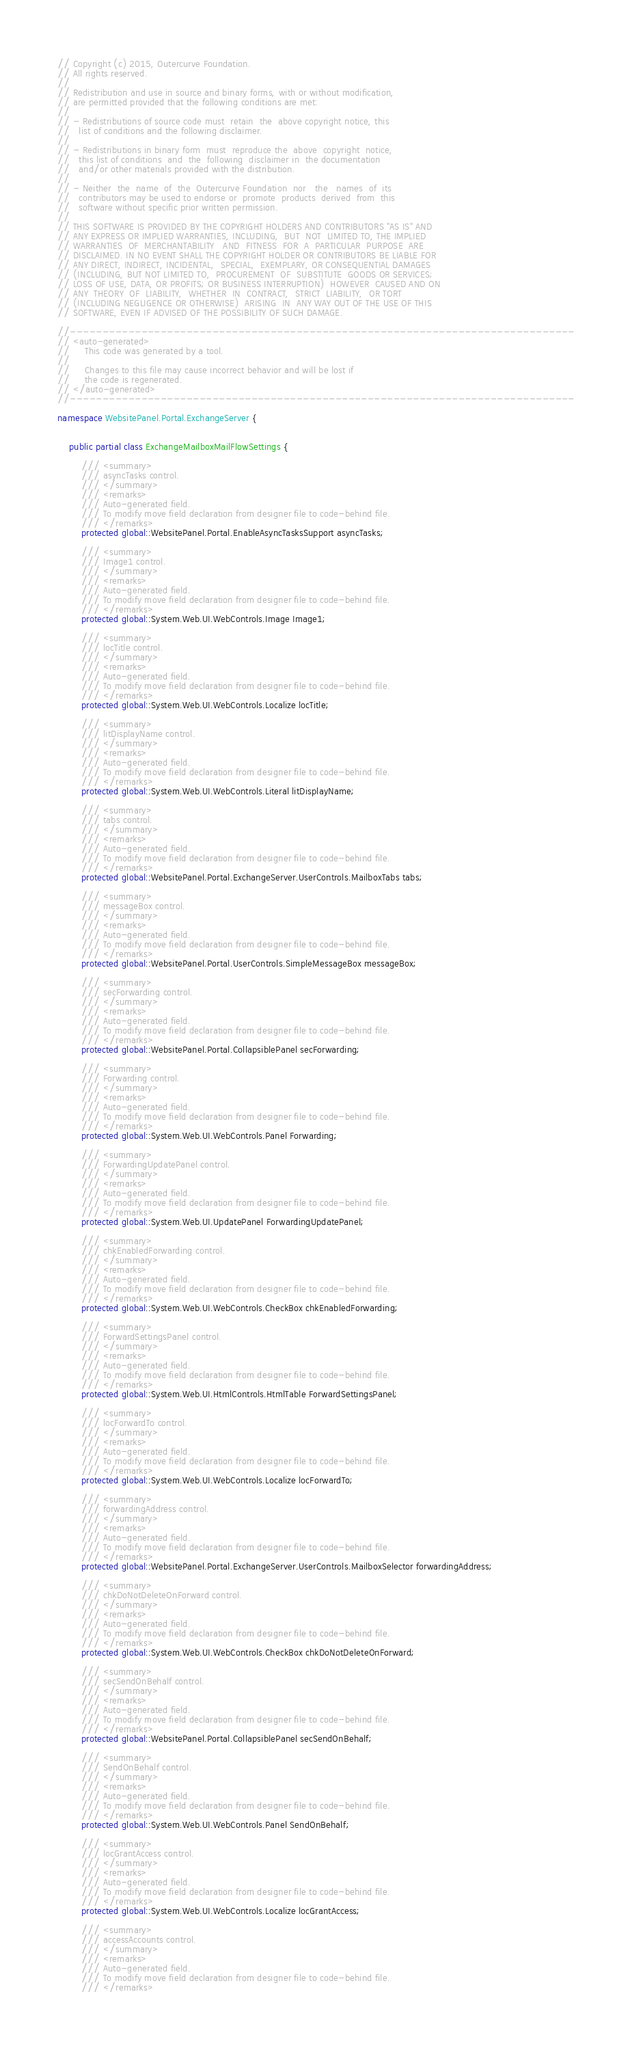<code> <loc_0><loc_0><loc_500><loc_500><_C#_>// Copyright (c) 2015, Outercurve Foundation.
// All rights reserved.
//
// Redistribution and use in source and binary forms, with or without modification,
// are permitted provided that the following conditions are met:
//
// - Redistributions of source code must  retain  the  above copyright notice, this
//   list of conditions and the following disclaimer.
//
// - Redistributions in binary form  must  reproduce the  above  copyright  notice,
//   this list of conditions  and  the  following  disclaimer in  the documentation
//   and/or other materials provided with the distribution.
//
// - Neither  the  name  of  the  Outercurve Foundation  nor   the   names  of  its
//   contributors may be used to endorse or  promote  products  derived  from  this
//   software without specific prior written permission.
//
// THIS SOFTWARE IS PROVIDED BY THE COPYRIGHT HOLDERS AND CONTRIBUTORS "AS IS" AND
// ANY EXPRESS OR IMPLIED WARRANTIES, INCLUDING,  BUT  NOT  LIMITED TO, THE IMPLIED
// WARRANTIES  OF  MERCHANTABILITY   AND  FITNESS  FOR  A  PARTICULAR  PURPOSE  ARE
// DISCLAIMED. IN NO EVENT SHALL THE COPYRIGHT HOLDER OR CONTRIBUTORS BE LIABLE FOR
// ANY DIRECT, INDIRECT, INCIDENTAL,  SPECIAL,  EXEMPLARY, OR CONSEQUENTIAL DAMAGES
// (INCLUDING, BUT NOT LIMITED TO,  PROCUREMENT  OF  SUBSTITUTE  GOODS OR SERVICES;
// LOSS OF USE, DATA, OR PROFITS; OR BUSINESS INTERRUPTION)  HOWEVER  CAUSED AND ON
// ANY  THEORY  OF  LIABILITY,  WHETHER  IN  CONTRACT,  STRICT  LIABILITY,  OR TORT
// (INCLUDING NEGLIGENCE OR OTHERWISE)  ARISING  IN  ANY WAY OUT OF THE USE OF THIS
// SOFTWARE, EVEN IF ADVISED OF THE POSSIBILITY OF SUCH DAMAGE.

//------------------------------------------------------------------------------
// <auto-generated>
//     This code was generated by a tool.
//
//     Changes to this file may cause incorrect behavior and will be lost if
//     the code is regenerated. 
// </auto-generated>
//------------------------------------------------------------------------------

namespace WebsitePanel.Portal.ExchangeServer {
    
    
    public partial class ExchangeMailboxMailFlowSettings {
        
        /// <summary>
        /// asyncTasks control.
        /// </summary>
        /// <remarks>
        /// Auto-generated field.
        /// To modify move field declaration from designer file to code-behind file.
        /// </remarks>
        protected global::WebsitePanel.Portal.EnableAsyncTasksSupport asyncTasks;
        
        /// <summary>
        /// Image1 control.
        /// </summary>
        /// <remarks>
        /// Auto-generated field.
        /// To modify move field declaration from designer file to code-behind file.
        /// </remarks>
        protected global::System.Web.UI.WebControls.Image Image1;
        
        /// <summary>
        /// locTitle control.
        /// </summary>
        /// <remarks>
        /// Auto-generated field.
        /// To modify move field declaration from designer file to code-behind file.
        /// </remarks>
        protected global::System.Web.UI.WebControls.Localize locTitle;
        
        /// <summary>
        /// litDisplayName control.
        /// </summary>
        /// <remarks>
        /// Auto-generated field.
        /// To modify move field declaration from designer file to code-behind file.
        /// </remarks>
        protected global::System.Web.UI.WebControls.Literal litDisplayName;
        
        /// <summary>
        /// tabs control.
        /// </summary>
        /// <remarks>
        /// Auto-generated field.
        /// To modify move field declaration from designer file to code-behind file.
        /// </remarks>
        protected global::WebsitePanel.Portal.ExchangeServer.UserControls.MailboxTabs tabs;
        
        /// <summary>
        /// messageBox control.
        /// </summary>
        /// <remarks>
        /// Auto-generated field.
        /// To modify move field declaration from designer file to code-behind file.
        /// </remarks>
        protected global::WebsitePanel.Portal.UserControls.SimpleMessageBox messageBox;
        
        /// <summary>
        /// secForwarding control.
        /// </summary>
        /// <remarks>
        /// Auto-generated field.
        /// To modify move field declaration from designer file to code-behind file.
        /// </remarks>
        protected global::WebsitePanel.Portal.CollapsiblePanel secForwarding;
        
        /// <summary>
        /// Forwarding control.
        /// </summary>
        /// <remarks>
        /// Auto-generated field.
        /// To modify move field declaration from designer file to code-behind file.
        /// </remarks>
        protected global::System.Web.UI.WebControls.Panel Forwarding;
        
        /// <summary>
        /// ForwardingUpdatePanel control.
        /// </summary>
        /// <remarks>
        /// Auto-generated field.
        /// To modify move field declaration from designer file to code-behind file.
        /// </remarks>
        protected global::System.Web.UI.UpdatePanel ForwardingUpdatePanel;
        
        /// <summary>
        /// chkEnabledForwarding control.
        /// </summary>
        /// <remarks>
        /// Auto-generated field.
        /// To modify move field declaration from designer file to code-behind file.
        /// </remarks>
        protected global::System.Web.UI.WebControls.CheckBox chkEnabledForwarding;
        
        /// <summary>
        /// ForwardSettingsPanel control.
        /// </summary>
        /// <remarks>
        /// Auto-generated field.
        /// To modify move field declaration from designer file to code-behind file.
        /// </remarks>
        protected global::System.Web.UI.HtmlControls.HtmlTable ForwardSettingsPanel;
        
        /// <summary>
        /// locForwardTo control.
        /// </summary>
        /// <remarks>
        /// Auto-generated field.
        /// To modify move field declaration from designer file to code-behind file.
        /// </remarks>
        protected global::System.Web.UI.WebControls.Localize locForwardTo;
        
        /// <summary>
        /// forwardingAddress control.
        /// </summary>
        /// <remarks>
        /// Auto-generated field.
        /// To modify move field declaration from designer file to code-behind file.
        /// </remarks>
        protected global::WebsitePanel.Portal.ExchangeServer.UserControls.MailboxSelector forwardingAddress;
        
        /// <summary>
        /// chkDoNotDeleteOnForward control.
        /// </summary>
        /// <remarks>
        /// Auto-generated field.
        /// To modify move field declaration from designer file to code-behind file.
        /// </remarks>
        protected global::System.Web.UI.WebControls.CheckBox chkDoNotDeleteOnForward;
        
        /// <summary>
        /// secSendOnBehalf control.
        /// </summary>
        /// <remarks>
        /// Auto-generated field.
        /// To modify move field declaration from designer file to code-behind file.
        /// </remarks>
        protected global::WebsitePanel.Portal.CollapsiblePanel secSendOnBehalf;
        
        /// <summary>
        /// SendOnBehalf control.
        /// </summary>
        /// <remarks>
        /// Auto-generated field.
        /// To modify move field declaration from designer file to code-behind file.
        /// </remarks>
        protected global::System.Web.UI.WebControls.Panel SendOnBehalf;
        
        /// <summary>
        /// locGrantAccess control.
        /// </summary>
        /// <remarks>
        /// Auto-generated field.
        /// To modify move field declaration from designer file to code-behind file.
        /// </remarks>
        protected global::System.Web.UI.WebControls.Localize locGrantAccess;
        
        /// <summary>
        /// accessAccounts control.
        /// </summary>
        /// <remarks>
        /// Auto-generated field.
        /// To modify move field declaration from designer file to code-behind file.
        /// </remarks></code> 